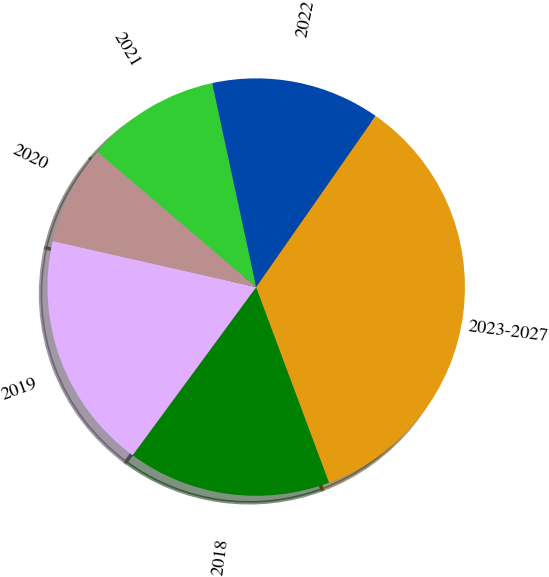Convert chart. <chart><loc_0><loc_0><loc_500><loc_500><pie_chart><fcel>2018<fcel>2019<fcel>2020<fcel>2021<fcel>2022<fcel>2023-2027<nl><fcel>15.77%<fcel>18.46%<fcel>7.69%<fcel>10.38%<fcel>13.08%<fcel>34.62%<nl></chart> 